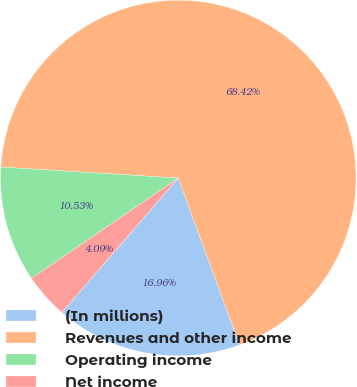Convert chart to OTSL. <chart><loc_0><loc_0><loc_500><loc_500><pie_chart><fcel>(In millions)<fcel>Revenues and other income<fcel>Operating income<fcel>Net income<nl><fcel>16.96%<fcel>68.42%<fcel>10.53%<fcel>4.09%<nl></chart> 